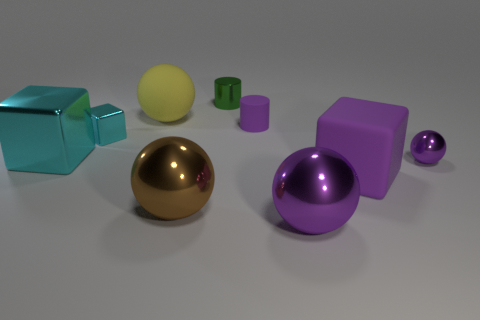Are any small gray rubber blocks visible?
Your response must be concise. No. Are there fewer shiny blocks that are in front of the large cyan object than large purple metal balls behind the large purple cube?
Offer a very short reply. No. The small thing to the left of the metal cylinder has what shape?
Offer a very short reply. Cube. Do the small purple sphere and the large brown sphere have the same material?
Keep it short and to the point. Yes. There is a tiny purple thing that is the same shape as the large yellow thing; what material is it?
Your response must be concise. Metal. Is the number of small cyan metal things to the right of the large purple shiny thing less than the number of tiny cyan cubes?
Keep it short and to the point. Yes. There is a large purple shiny ball; how many small purple objects are in front of it?
Offer a terse response. 0. Do the purple metal thing that is on the right side of the big purple metal sphere and the cyan object behind the big cyan shiny cube have the same shape?
Give a very brief answer. No. The large thing that is to the right of the big matte ball and behind the brown sphere has what shape?
Give a very brief answer. Cube. There is a cylinder that is made of the same material as the big yellow sphere; what is its size?
Offer a very short reply. Small. 